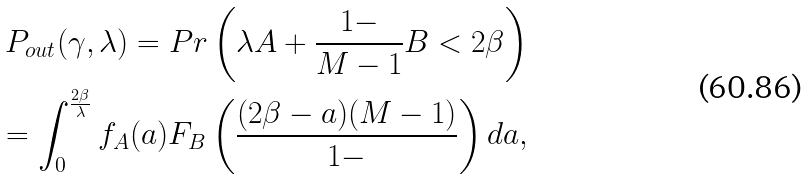Convert formula to latex. <formula><loc_0><loc_0><loc_500><loc_500>P _ { o u t } ( \gamma , \lambda ) = P r \left ( \lambda A + \frac { 1 - } { M - 1 } B < 2 \beta \right ) & \\ = \int _ { 0 } ^ { \frac { 2 \beta } { \lambda } } f _ { A } ( a ) F _ { B } \left ( \frac { ( 2 \beta - a ) ( M - 1 ) } { 1 - } \right ) d a , &</formula> 